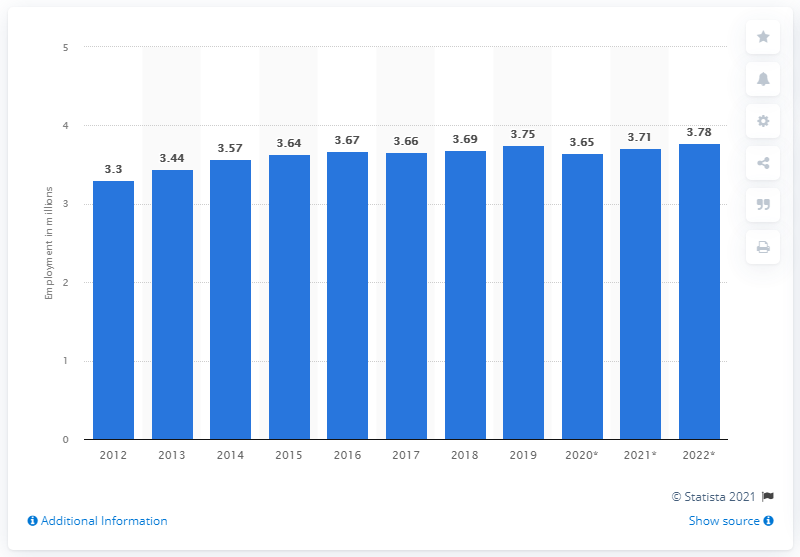Specify some key components in this picture. In 2019, approximately 3.78 million people were employed in Singapore. 